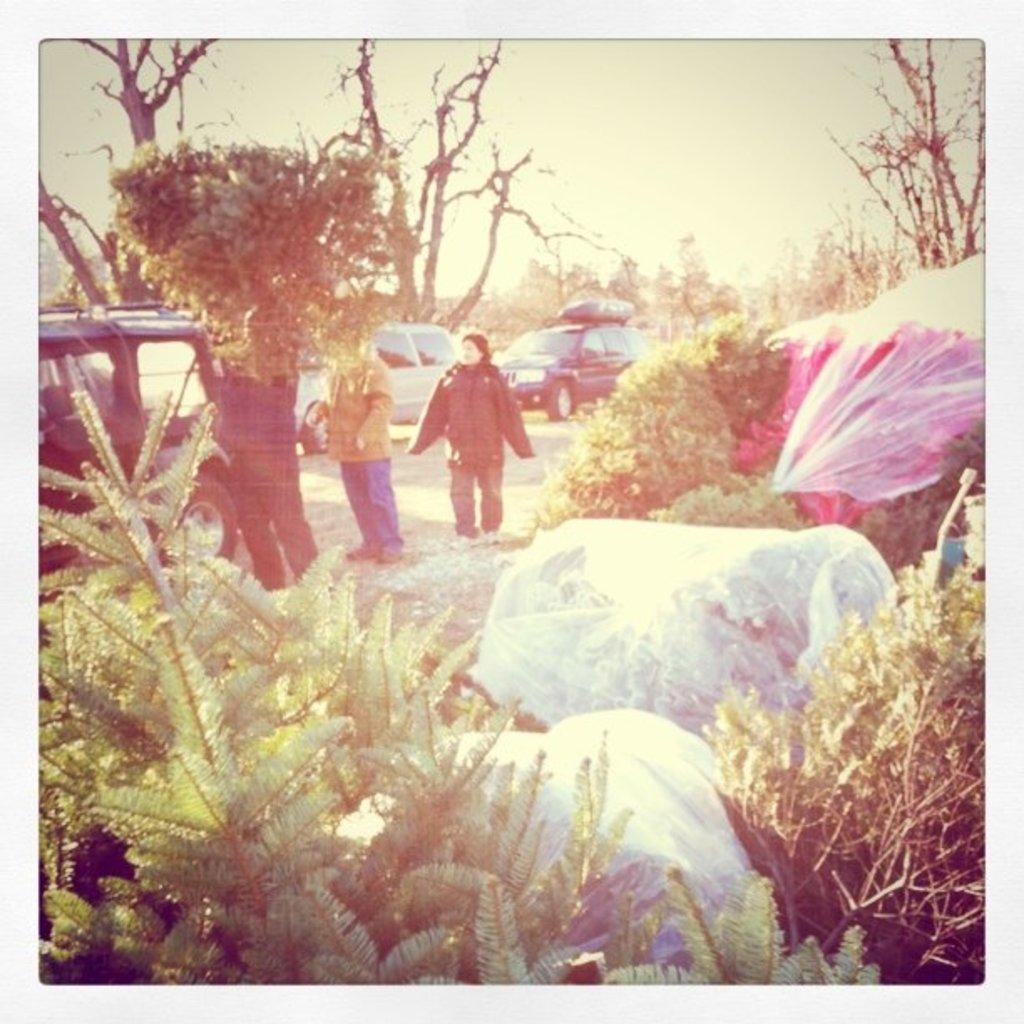What can be seen on the road in the image? There are vehicles on the road in the image. How many people are standing in the image? There are three persons standing in the image. What type of vegetation is present in the image? There are plants and trees in the image. What objects can be seen being carried by the people in the image? There are bags in the image. What is visible in the background of the image? The sky is visible in the background of the image. What is the chance of winning a lottery in the image? There is no mention of a lottery or any chance of winning in the image. How many heads are visible in the image? The provided facts do not mention the number of heads or faces visible in the image. 